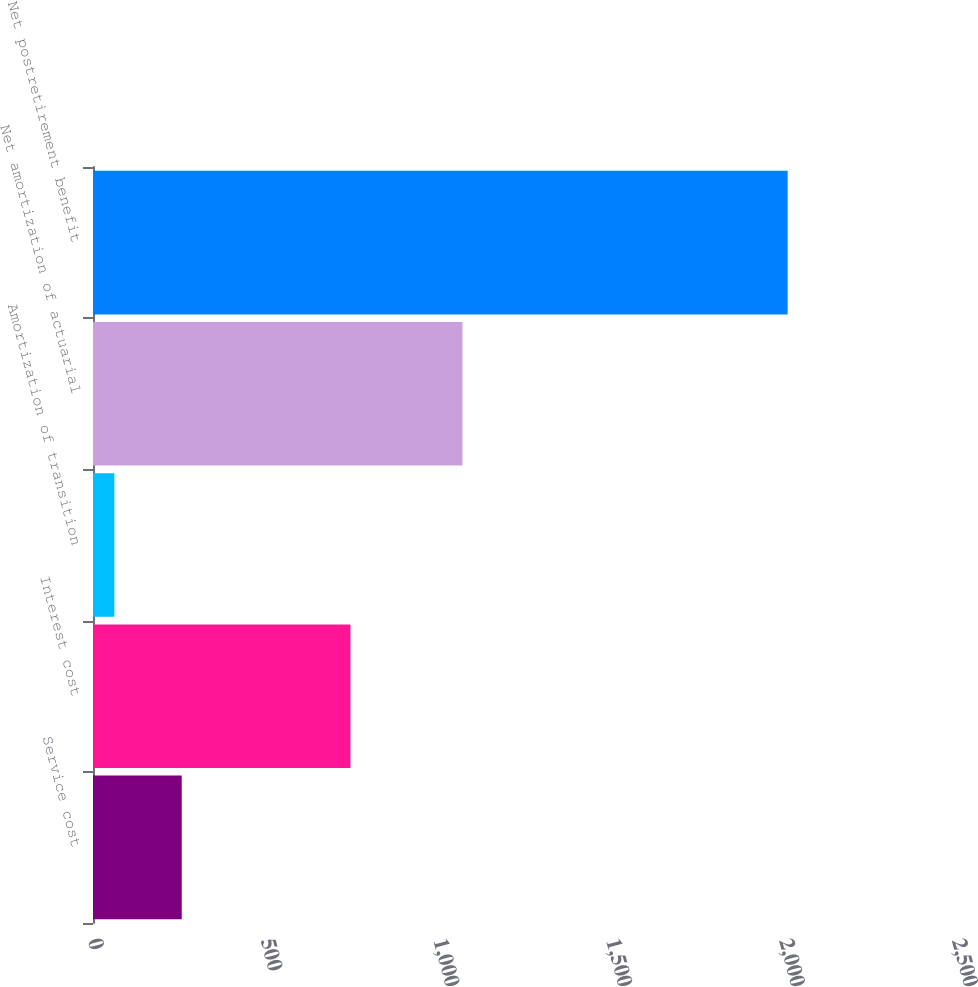Convert chart. <chart><loc_0><loc_0><loc_500><loc_500><bar_chart><fcel>Service cost<fcel>Interest cost<fcel>Amortization of transition<fcel>Net amortization of actuarial<fcel>Net postretirement benefit<nl><fcel>256.8<fcel>745<fcel>62<fcel>1069<fcel>2010<nl></chart> 